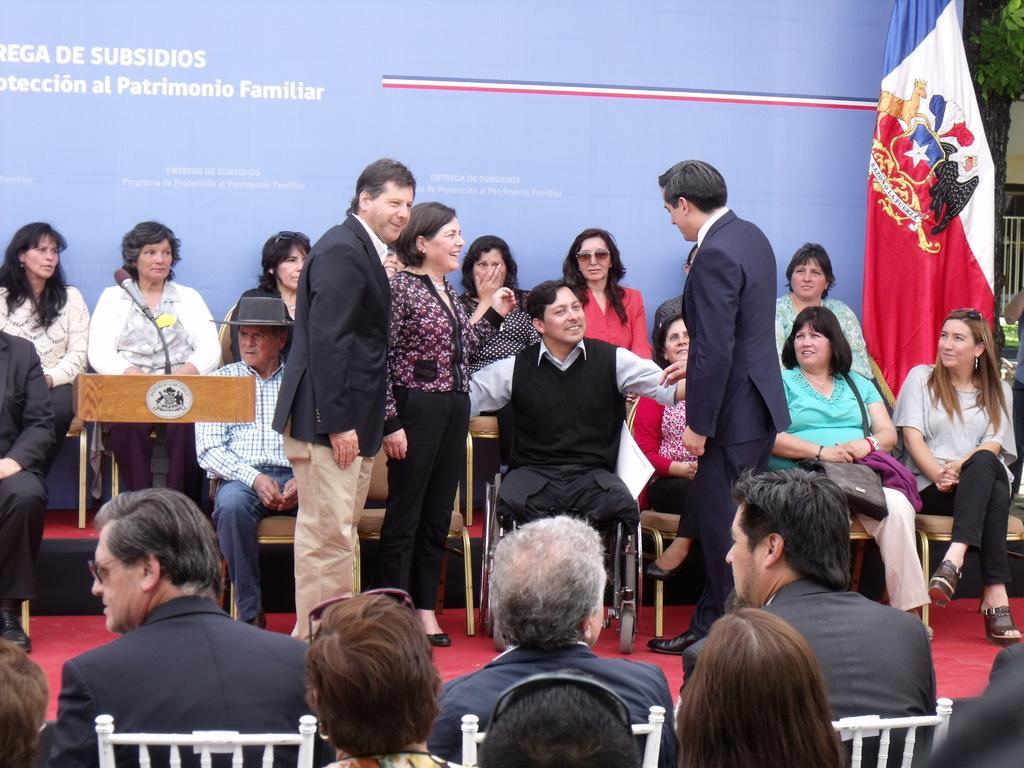Describe this image in one or two sentences. There is a person in black color jacket, sitting on a wheel chair, which is on the red color carpet, near other three persons who are standing on the stage. In front of them, there are persons sitting on white color chairs. In the background, there are persons sitting on chairs near a blue color hoarding and a flag. 